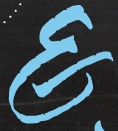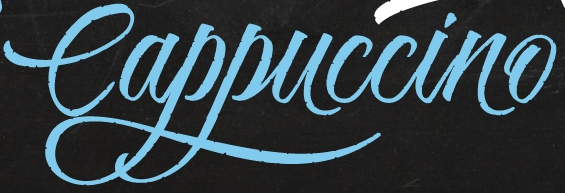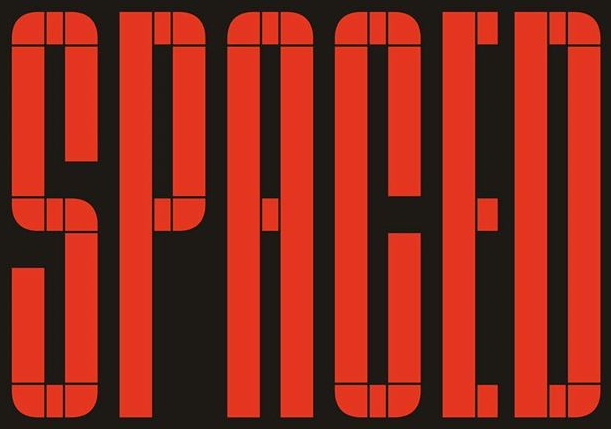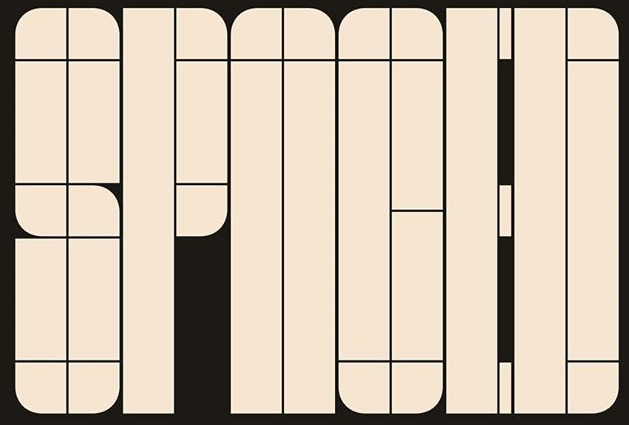What words are shown in these images in order, separated by a semicolon? E; Cappuccino; SPACED; SPNOED 